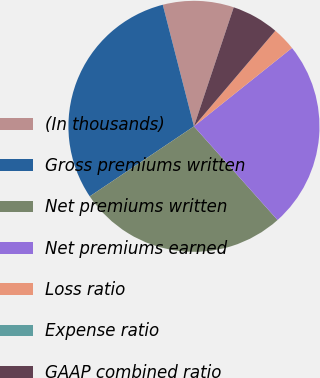Convert chart. <chart><loc_0><loc_0><loc_500><loc_500><pie_chart><fcel>(In thousands)<fcel>Gross premiums written<fcel>Net premiums written<fcel>Net premiums earned<fcel>Loss ratio<fcel>Expense ratio<fcel>GAAP combined ratio<nl><fcel>9.13%<fcel>30.42%<fcel>27.18%<fcel>24.14%<fcel>3.04%<fcel>0.0%<fcel>6.09%<nl></chart> 